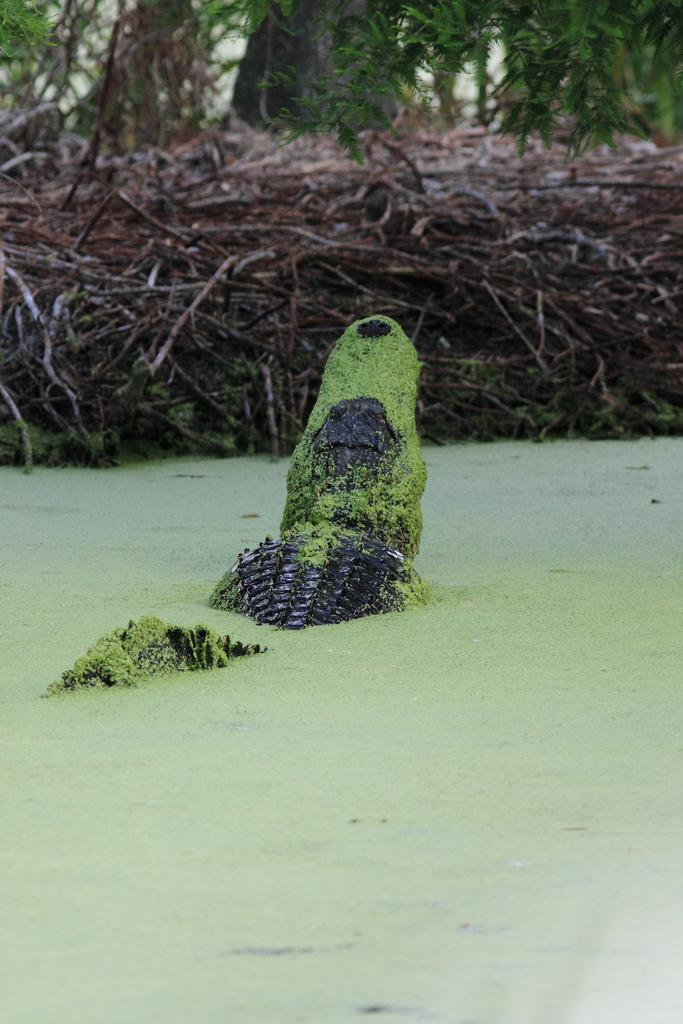What animal is present in the image? There is a crocodile in the image. What is the color of the water surrounding the crocodile? The crocodile is in green-colored water. What type of vegetation can be seen in the image? There are trees visible in the image. What type of guitar can be seen in the stomach of the crocodile in the image? There is no guitar present in the image, and the crocodile's stomach is not visible. 